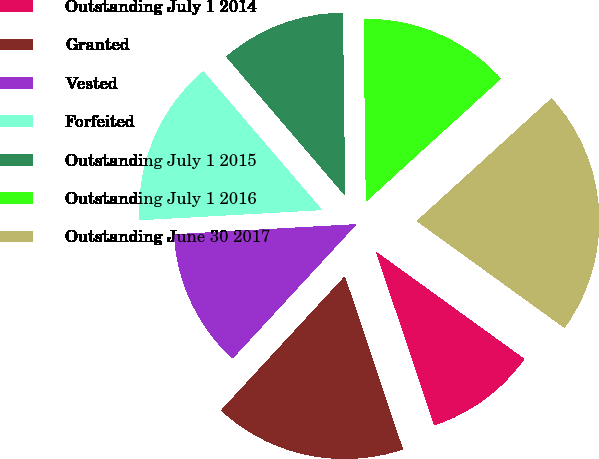Convert chart to OTSL. <chart><loc_0><loc_0><loc_500><loc_500><pie_chart><fcel>Outstanding July 1 2014<fcel>Granted<fcel>Vested<fcel>Forfeited<fcel>Outstanding July 1 2015<fcel>Outstanding July 1 2016<fcel>Outstanding June 30 2017<nl><fcel>9.89%<fcel>17.02%<fcel>12.25%<fcel>14.62%<fcel>11.07%<fcel>13.44%<fcel>21.71%<nl></chart> 